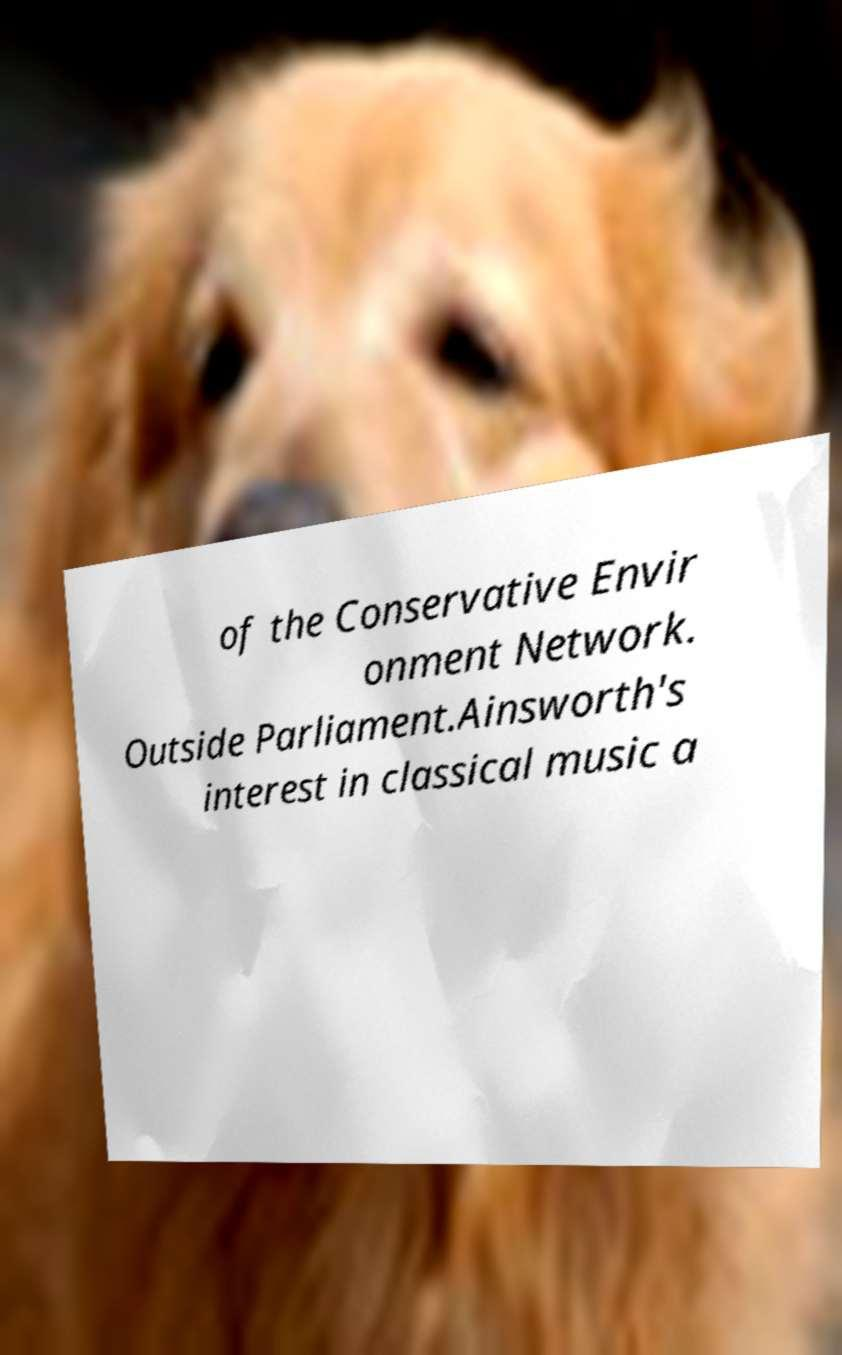There's text embedded in this image that I need extracted. Can you transcribe it verbatim? of the Conservative Envir onment Network. Outside Parliament.Ainsworth's interest in classical music a 